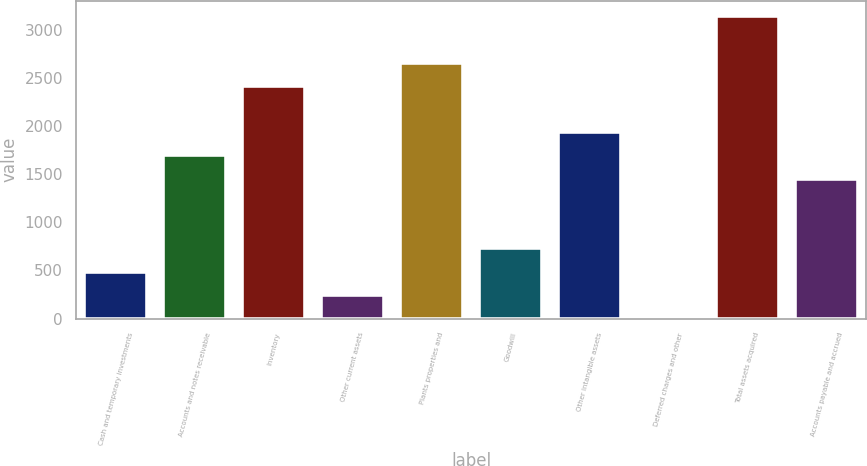Convert chart to OTSL. <chart><loc_0><loc_0><loc_500><loc_500><bar_chart><fcel>Cash and temporary investments<fcel>Accounts and notes receivable<fcel>Inventory<fcel>Other current assets<fcel>Plants properties and<fcel>Goodwill<fcel>Other intangible assets<fcel>Deferred charges and other<fcel>Total assets acquired<fcel>Accounts payable and accrued<nl><fcel>488.8<fcel>1695.8<fcel>2420<fcel>247.4<fcel>2661.4<fcel>730.2<fcel>1937.2<fcel>6<fcel>3144.2<fcel>1454.4<nl></chart> 